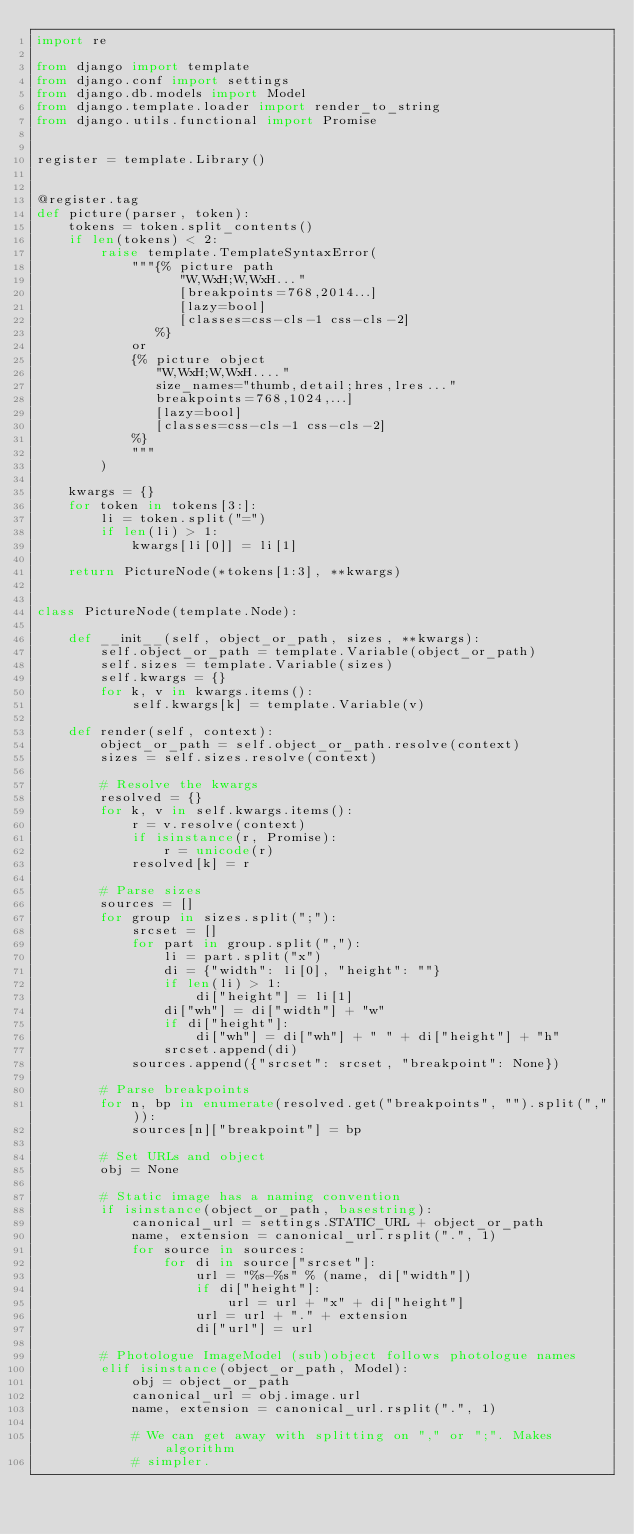<code> <loc_0><loc_0><loc_500><loc_500><_Python_>import re

from django import template
from django.conf import settings
from django.db.models import Model
from django.template.loader import render_to_string
from django.utils.functional import Promise


register = template.Library()


@register.tag
def picture(parser, token):
    tokens = token.split_contents()
    if len(tokens) < 2:
        raise template.TemplateSyntaxError(
            """{% picture path
                  "W,WxH;W,WxH..."
                  [breakpoints=768,2014...]
                  [lazy=bool]
                  [classes=css-cls-1 css-cls-2]
               %}
            or
            {% picture object
               "W,WxH;W,WxH...."
               size_names="thumb,detail;hres,lres..."
               breakpoints=768,1024,...]
               [lazy=bool]
               [classes=css-cls-1 css-cls-2]
            %}
            """
        )

    kwargs = {}
    for token in tokens[3:]:
        li = token.split("=")
        if len(li) > 1:
            kwargs[li[0]] = li[1]

    return PictureNode(*tokens[1:3], **kwargs)


class PictureNode(template.Node):

    def __init__(self, object_or_path, sizes, **kwargs):
        self.object_or_path = template.Variable(object_or_path)
        self.sizes = template.Variable(sizes)
        self.kwargs = {}
        for k, v in kwargs.items():
            self.kwargs[k] = template.Variable(v)

    def render(self, context):
        object_or_path = self.object_or_path.resolve(context)
        sizes = self.sizes.resolve(context)

        # Resolve the kwargs
        resolved = {}
        for k, v in self.kwargs.items():
            r = v.resolve(context)
            if isinstance(r, Promise):
                r = unicode(r)
            resolved[k] = r

        # Parse sizes
        sources = []
        for group in sizes.split(";"):
            srcset = []
            for part in group.split(","):
                li = part.split("x")
                di = {"width": li[0], "height": ""}
                if len(li) > 1:
                    di["height"] = li[1]
                di["wh"] = di["width"] + "w"
                if di["height"]:
                    di["wh"] = di["wh"] + " " + di["height"] + "h"
                srcset.append(di)
            sources.append({"srcset": srcset, "breakpoint": None})

        # Parse breakpoints
        for n, bp in enumerate(resolved.get("breakpoints", "").split(",")):
            sources[n]["breakpoint"] = bp

        # Set URLs and object
        obj = None

        # Static image has a naming convention
        if isinstance(object_or_path, basestring):
            canonical_url = settings.STATIC_URL + object_or_path
            name, extension = canonical_url.rsplit(".", 1)
            for source in sources:
                for di in source["srcset"]:
                    url = "%s-%s" % (name, di["width"])
                    if di["height"]:
                        url = url + "x" + di["height"]
                    url = url + "." + extension
                    di["url"] = url

        # Photologue ImageModel (sub)object follows photologue names
        elif isinstance(object_or_path, Model):
            obj = object_or_path
            canonical_url = obj.image.url
            name, extension = canonical_url.rsplit(".", 1)

            # We can get away with splitting on "," or ";". Makes algorithm
            # simpler.</code> 